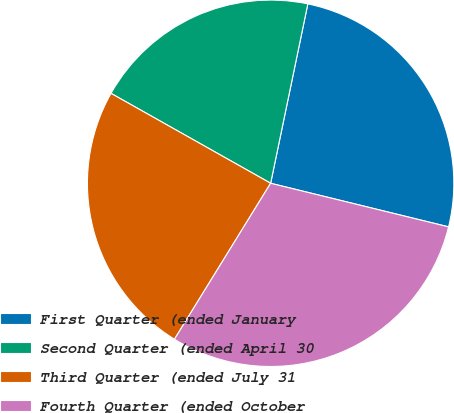Convert chart. <chart><loc_0><loc_0><loc_500><loc_500><pie_chart><fcel>First Quarter (ended January<fcel>Second Quarter (ended April 30<fcel>Third Quarter (ended July 31<fcel>Fourth Quarter (ended October<nl><fcel>25.57%<fcel>20.09%<fcel>24.37%<fcel>29.97%<nl></chart> 